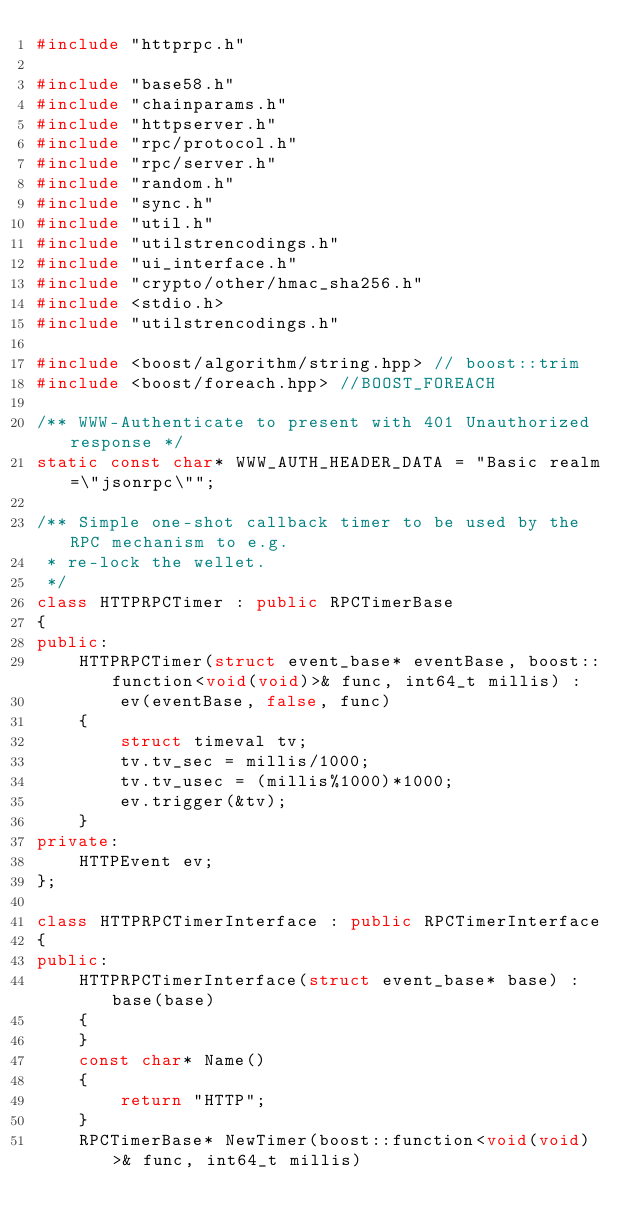<code> <loc_0><loc_0><loc_500><loc_500><_C++_>#include "httprpc.h"

#include "base58.h"
#include "chainparams.h"
#include "httpserver.h"
#include "rpc/protocol.h"
#include "rpc/server.h"
#include "random.h"
#include "sync.h"
#include "util.h"
#include "utilstrencodings.h"
#include "ui_interface.h"
#include "crypto/other/hmac_sha256.h"
#include <stdio.h>
#include "utilstrencodings.h"

#include <boost/algorithm/string.hpp> // boost::trim
#include <boost/foreach.hpp> //BOOST_FOREACH

/** WWW-Authenticate to present with 401 Unauthorized response */
static const char* WWW_AUTH_HEADER_DATA = "Basic realm=\"jsonrpc\"";

/** Simple one-shot callback timer to be used by the RPC mechanism to e.g.
 * re-lock the wellet.
 */
class HTTPRPCTimer : public RPCTimerBase
{
public:
    HTTPRPCTimer(struct event_base* eventBase, boost::function<void(void)>& func, int64_t millis) :
        ev(eventBase, false, func)
    {
        struct timeval tv;
        tv.tv_sec = millis/1000;
        tv.tv_usec = (millis%1000)*1000;
        ev.trigger(&tv);
    }
private:
    HTTPEvent ev;
};

class HTTPRPCTimerInterface : public RPCTimerInterface
{
public:
    HTTPRPCTimerInterface(struct event_base* base) : base(base)
    {
    }
    const char* Name()
    {
        return "HTTP";
    }
    RPCTimerBase* NewTimer(boost::function<void(void)>& func, int64_t millis)</code> 